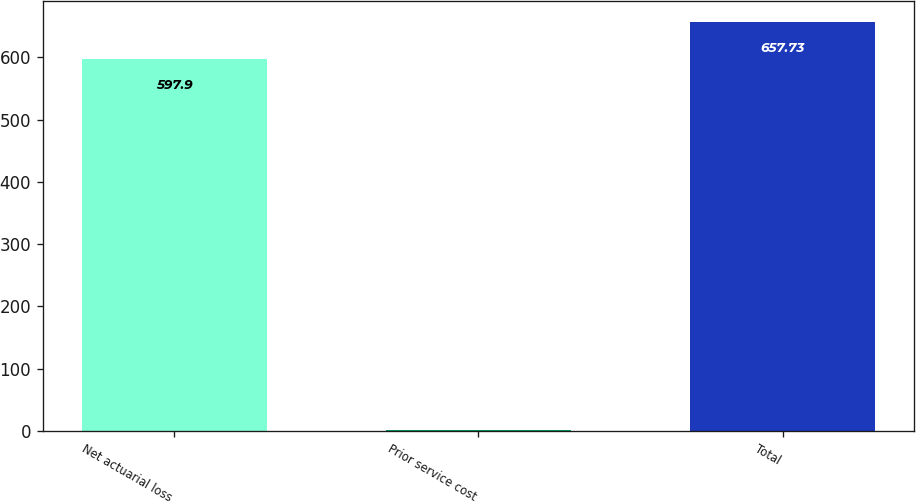<chart> <loc_0><loc_0><loc_500><loc_500><bar_chart><fcel>Net actuarial loss<fcel>Prior service cost<fcel>Total<nl><fcel>597.9<fcel>1.1<fcel>657.73<nl></chart> 